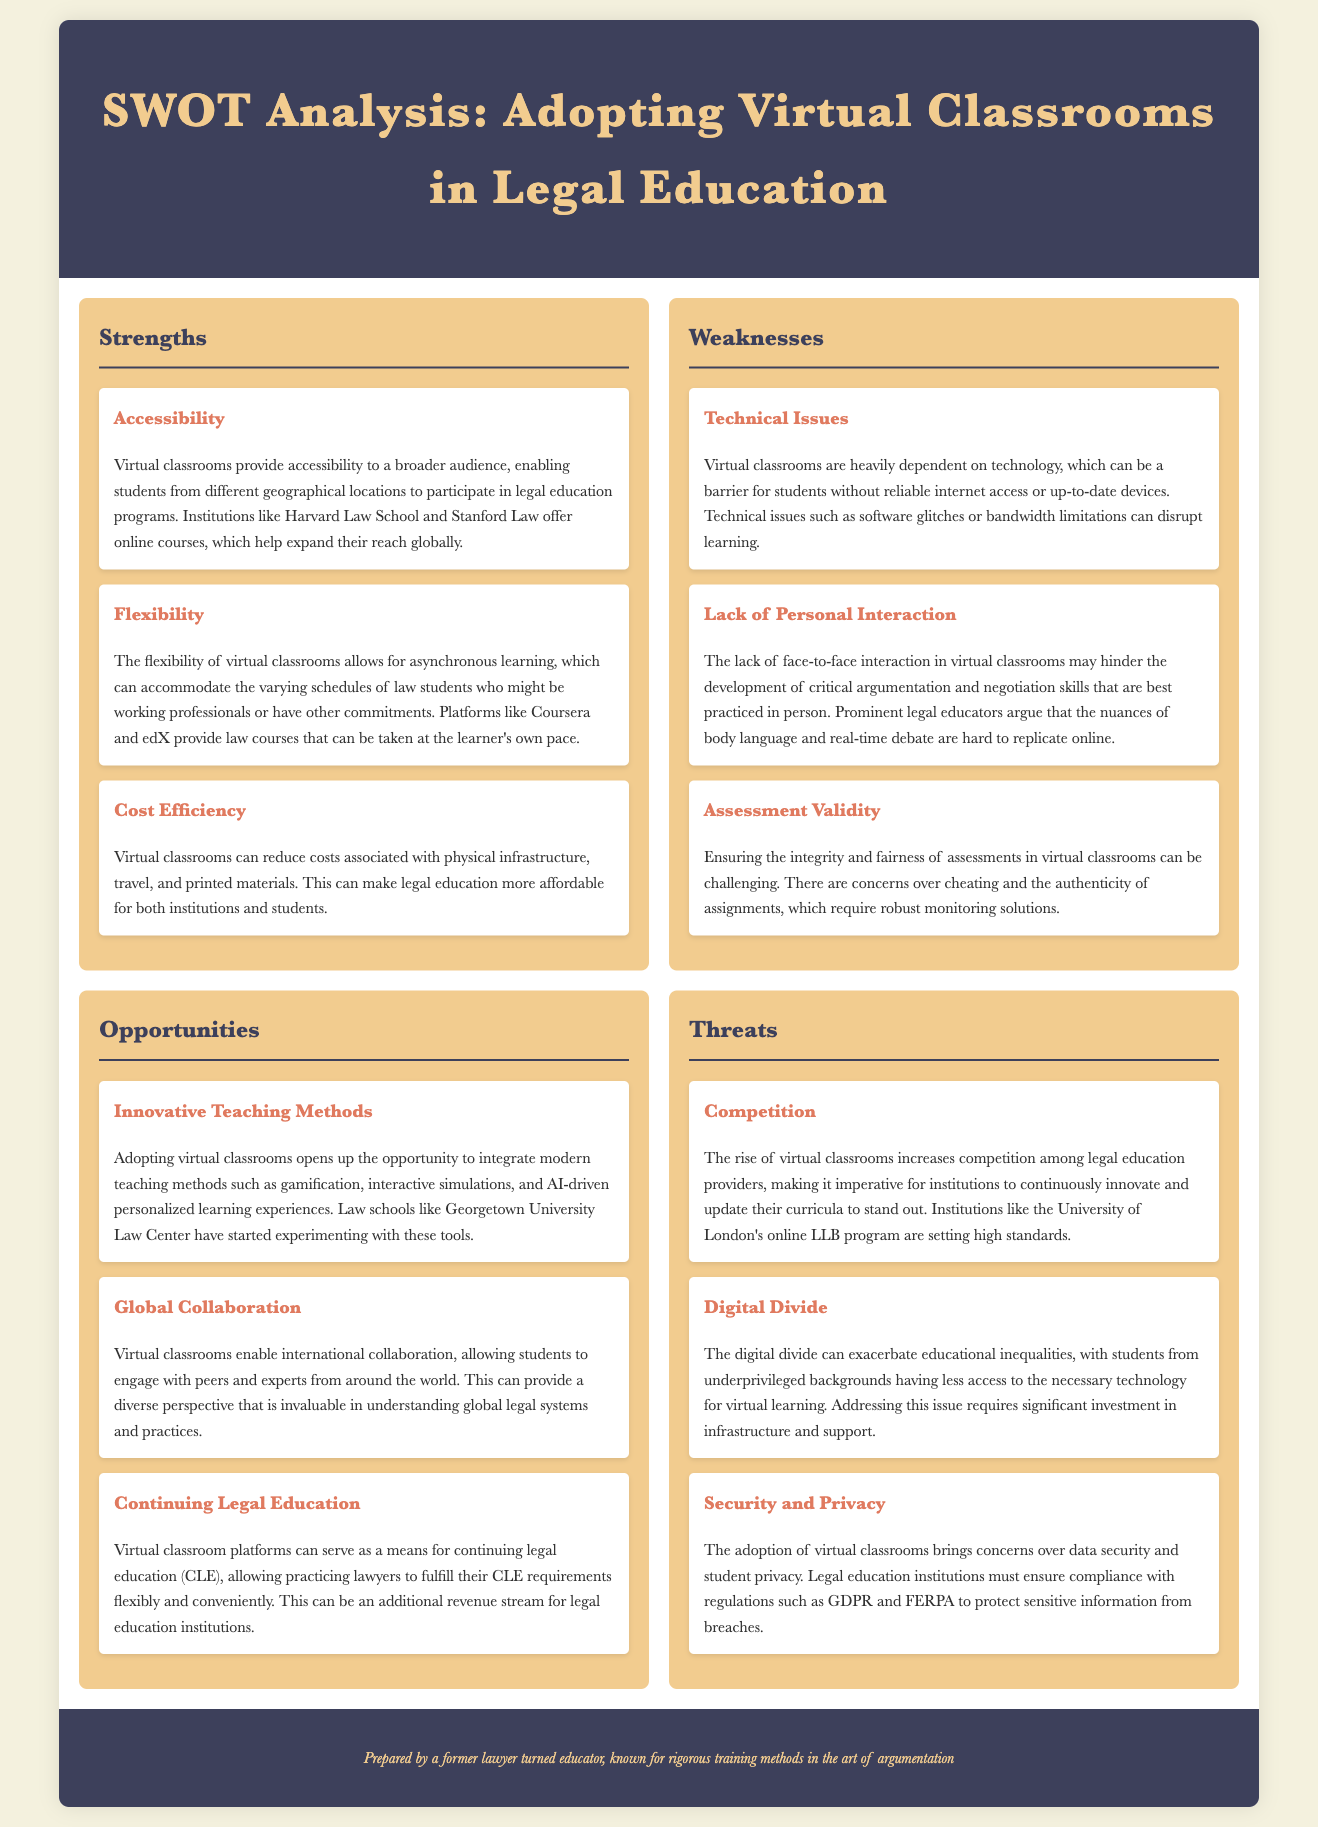what is one strength of adopting virtual classrooms? The document lists accessibility, flexibility, and cost efficiency as strengths of virtual classrooms.
Answer: Accessibility what is a weakness related to technical aspects in virtual classrooms? The weaknesses outlined include technical issues, lack of personal interaction, and assessment validity.
Answer: Technical Issues how can virtual classrooms contribute to educational opportunities? Opportunities identified include innovative teaching methods, global collaboration, and continuing legal education.
Answer: Innovative Teaching Methods what is a potential threat mentioned in the analysis? The threats discussed are competition, the digital divide, and security and privacy.
Answer: Competition which legal education institution is noted for its online courses? The document mentions Harvard Law School and Stanford Law for offering online courses.
Answer: Harvard Law School how does virtual learning help accommodate students' schedules? Flexibility in virtual classrooms allows asynchronous learning to fit varying schedules.
Answer: Flexibility what concern is raised about assessments in virtual classrooms? The document mentions concerns about integrity and fairness of assessments as a challenge.
Answer: Assessment Validity what can virtual classrooms provide to practicing lawyers according to the document? The document mentions that virtual classrooms can serve for continuing legal education (CLE).
Answer: Continuing Legal Education how does the document describe the issue of access to technology? The digital divide is mentioned as exacerbating educational inequalities.
Answer: Digital Divide what is essential for protecting data in virtual classrooms? The document emphasizes the need for compliance with GDPR and FERPA regulations.
Answer: Compliance 